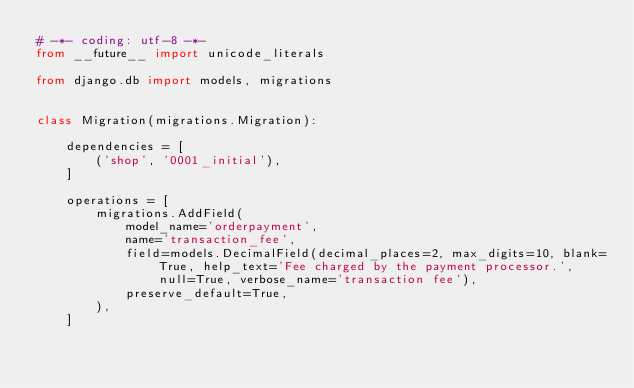<code> <loc_0><loc_0><loc_500><loc_500><_Python_># -*- coding: utf-8 -*-
from __future__ import unicode_literals

from django.db import models, migrations


class Migration(migrations.Migration):

    dependencies = [
        ('shop', '0001_initial'),
    ]

    operations = [
        migrations.AddField(
            model_name='orderpayment',
            name='transaction_fee',
            field=models.DecimalField(decimal_places=2, max_digits=10, blank=True, help_text='Fee charged by the payment processor.', null=True, verbose_name='transaction fee'),
            preserve_default=True,
        ),
    ]
</code> 